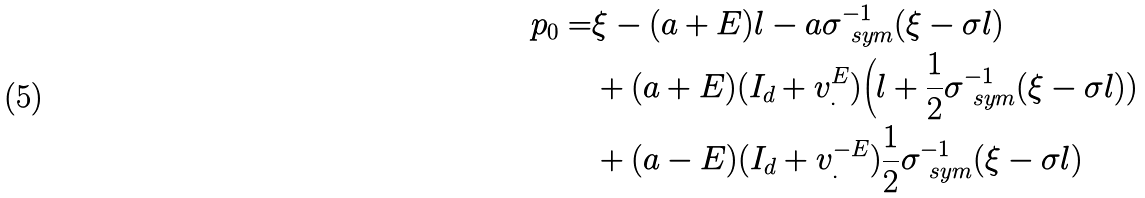<formula> <loc_0><loc_0><loc_500><loc_500>p _ { 0 } = & \xi - ( a + E ) l - a \sigma _ { \ s y m } ^ { - 1 } ( \xi - \sigma l ) \\ & + ( a + E ) ( I _ { d } + v _ { . } ^ { E } ) \Big ( l + \frac { 1 } { 2 } \sigma _ { \ s y m } ^ { - 1 } ( \xi - \sigma l ) ) \\ & + ( a - E ) ( I _ { d } + v _ { . } ^ { - E } ) \frac { 1 } { 2 } \sigma _ { \ s y m } ^ { - 1 } ( \xi - \sigma l )</formula> 